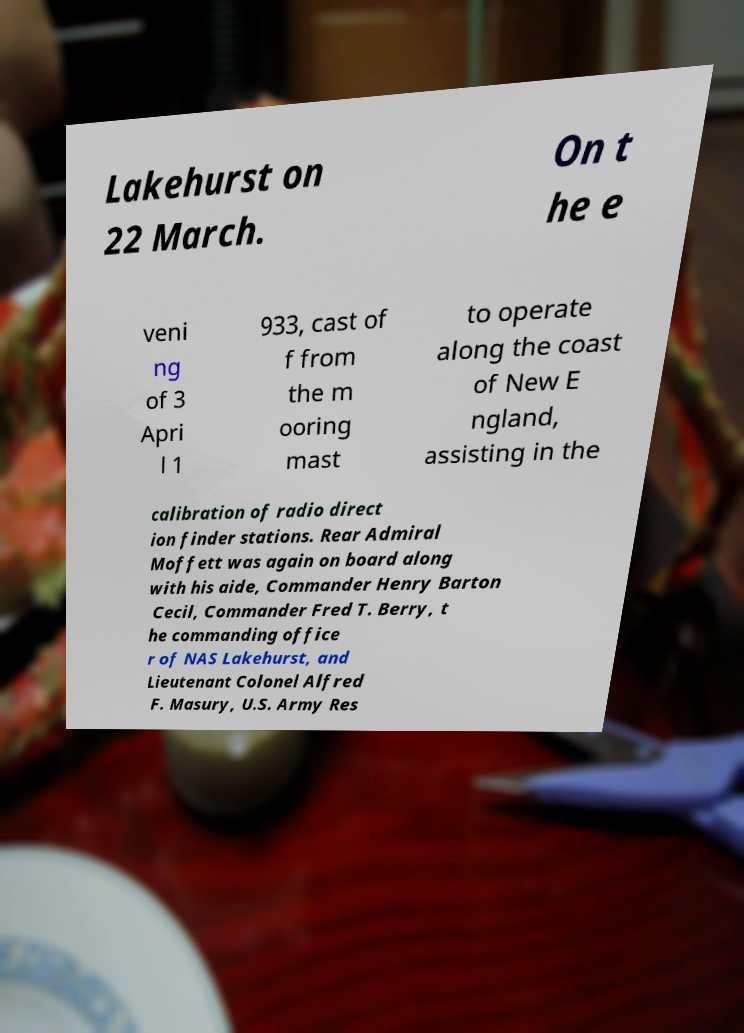Please read and relay the text visible in this image. What does it say? Lakehurst on 22 March. On t he e veni ng of 3 Apri l 1 933, cast of f from the m ooring mast to operate along the coast of New E ngland, assisting in the calibration of radio direct ion finder stations. Rear Admiral Moffett was again on board along with his aide, Commander Henry Barton Cecil, Commander Fred T. Berry, t he commanding office r of NAS Lakehurst, and Lieutenant Colonel Alfred F. Masury, U.S. Army Res 